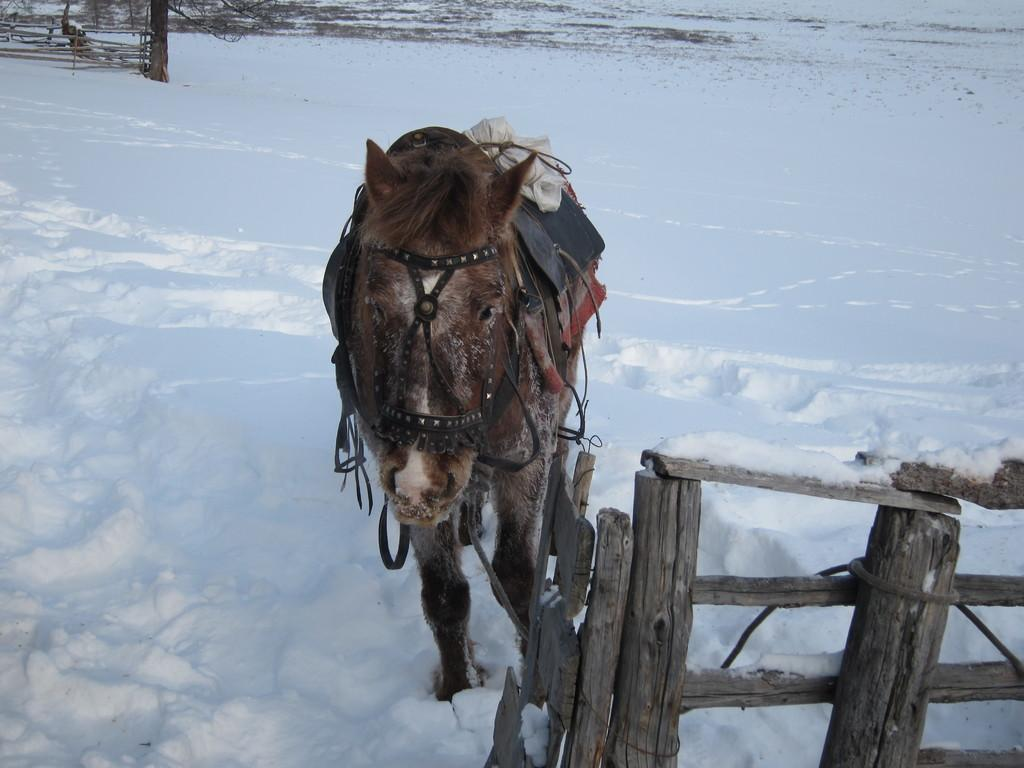What animal can be seen in the image? There is a donkey in the image. What is the surface the donkey is standing on? The donkey is standing on a snow surface. What type of fencing is present in the image? There is a wooden fencing in the image. Can you describe the background of the image? In the background, there is another wooden fencing. What else can be seen on the snow surface in the image? There are plants on the snow surface in the image. How many quarters does the donkey have in the image? The donkey does not have any quarters in the image, as quarters are a form of currency and not something that can be possessed by animals. 